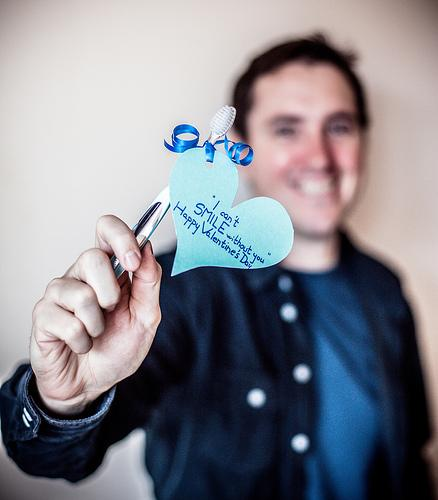What is the emotion conveyed by the person in the image? The man in the image appears to be happy, as he has a smiling face possibly showing his teeth. Count the number of visible objects in the image and describe them. There are seven visible objects: a man, a plastic toothbrush, a heart-shaped note, a blue ribbon, a denim shirt, a light blue shirt, and white buttons. Using the given information, deduce what the man might be feeling or thinking. The man is likely feeling happy or pleased, as evidenced by his smiling face, and he might be thinking about the message on the heart-shaped note attached to the toothbrush. Examine the man's facial features and describe them briefly. The man has a smiling face, possibly showing his teeth, a nose, an eye, and brown eyebrows. In this image, analyze the interaction between the toothbrush and the heart-shaped note. The interaction between the toothbrush and the heart-shaped note is that the note is tied to the toothbrush with a blue ribbon, creating a connection between the two objects. Evaluate the quality of the captured image based on the provided information about objects. The image quality seems to be good, as various objects like buttons, ribbons, notes, and facial features seem to be represented with detailed bounding boxes indicating their positions and sizes. Explain the significance of the heart-shaped note in the image. The heart-shaped note is significant because it is attached to the toothbrush with a blue ribbon and has a handwritten message on it, possibly expressing love or a personal message. What type of shirt is the man wearing under the denim shirt? The man is wearing a light blue shirt under the denim shirt. What do you think is the purpose of attaching a note to the toothbrush? The purpose of attaching a note to the toothbrush could be to convey a personal message, a reminder, or an expression of love or affection. Can you provide a summary of the scene in the image? A man with dark hair is smiling and holding a new toothbrush with a heart-shaped note attached by a blue ribbon. He is wearing a denim shirt over a light blue shirt. Identify the objects and their features in the image. man with dark hair, plastic toothbrush, blue curled ribbon, heart-shaped paper note, light blue shirt, denim shirt with white buttons on cuff and pockets, hand with clean fingernails, brand new toothbrush, blue print on paper Can you find the red umbrella located near the toothbrush? Make sure to look closely, as it might be partially hidden. No, it's not mentioned in the image. Describe any unusual aspects or abnormalities in the image. The toothbrush with a note tied to it is an unusual aspect of the image. Which object is in the left-top corner of the image with coordinates X:75 and Y:105? The plastic toothbrush with a note tied to it is in the left-top corner. Locate the fingers with clean fingernails in the image. The fingers with clean fingernails can be found at coordinates X:24 Y:223 with Width:122 Height:122. What is the color of the man's hair in the image? The man has dark brown hair. What is the appearance of the man's eyebrows? The man has brown eyebrows. Identify the background object that is under the denim shirt. The object under the denim shirt is a light blue shirt. What is the color of the ribbon tied around the toothbrush? The ribbon is blue in color. What kind of sentiment does the image create? The image creates a positive and thoughtful sentiment. What is written on the heart-shaped paper note? The writing is not clearly discernible, as it is a dark blue handwriting on a light blue paper. Describe the scene depicted in the image. A smiling man with dark hair wearing a denim shirt and a light blue shirt underneath is holding a new plastic toothbrush with a blue curled ribbon and a heart-shaped paper note tied to it. Analyze the interactions between the objects in the image. The hand holds the toothbrush, the ribbon ties the note to the toothbrush, and the man holds the toothbrush while wearing the shirts. What shape is the paper note tied to the toothbrush? The paper note is heart-shaped. Evaluate the quality of this image. The image has good quality, as the objects and their features are clearly visible. Provide a description of the handwritten note based on its appearance. The note is heart-shaped, light blue, with dark blue handwriting, and tied to the toothbrush by a blue curled ribbon. What are the attributes of the toothbrush? The toothbrush is plastic, brand new, and has a heart-shaped paper note tied to it with a blue curled ribbon. Are the man's teeth visible in the image? Yes, the man's teeth are visible as he is smiling. 